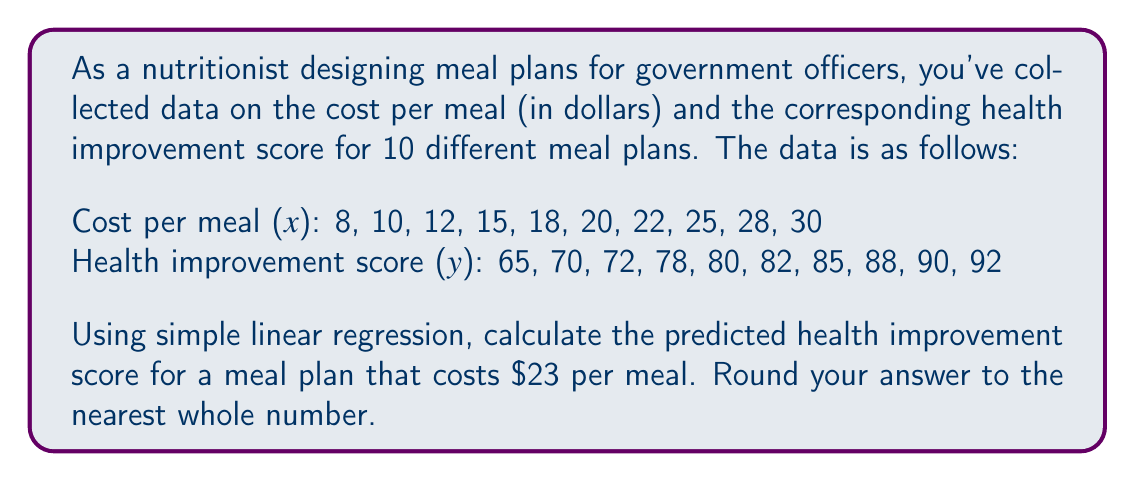What is the answer to this math problem? To solve this problem, we'll use simple linear regression to find the line of best fit and then use it to predict the health improvement score for a $23 meal.

Step 1: Calculate the means of x and y
$\bar{x} = \frac{8 + 10 + 12 + 15 + 18 + 20 + 22 + 25 + 28 + 30}{10} = 18.8$
$\bar{y} = \frac{65 + 70 + 72 + 78 + 80 + 82 + 85 + 88 + 90 + 92}{10} = 80.2$

Step 2: Calculate the slope (b) of the regression line
$b = \frac{\sum{(x_i - \bar{x})(y_i - \bar{y})}}{\sum{(x_i - \bar{x})^2}}$

$\sum{(x_i - \bar{x})(y_i - \bar{y})} = 1053.6$
$\sum{(x_i - \bar{x})^2} = 462.4$

$b = \frac{1053.6}{462.4} = 2.28$

Step 3: Calculate the y-intercept (a) of the regression line
$a = \bar{y} - b\bar{x}$
$a = 80.2 - (2.28 \times 18.8) = 37.344$

Step 4: Form the regression equation
$y = a + bx$
$y = 37.344 + 2.28x$

Step 5: Predict the health improvement score for a $23 meal
$y = 37.344 + 2.28(23) = 89.784$

Step 6: Round to the nearest whole number
89.784 rounds to 90
Answer: 90 